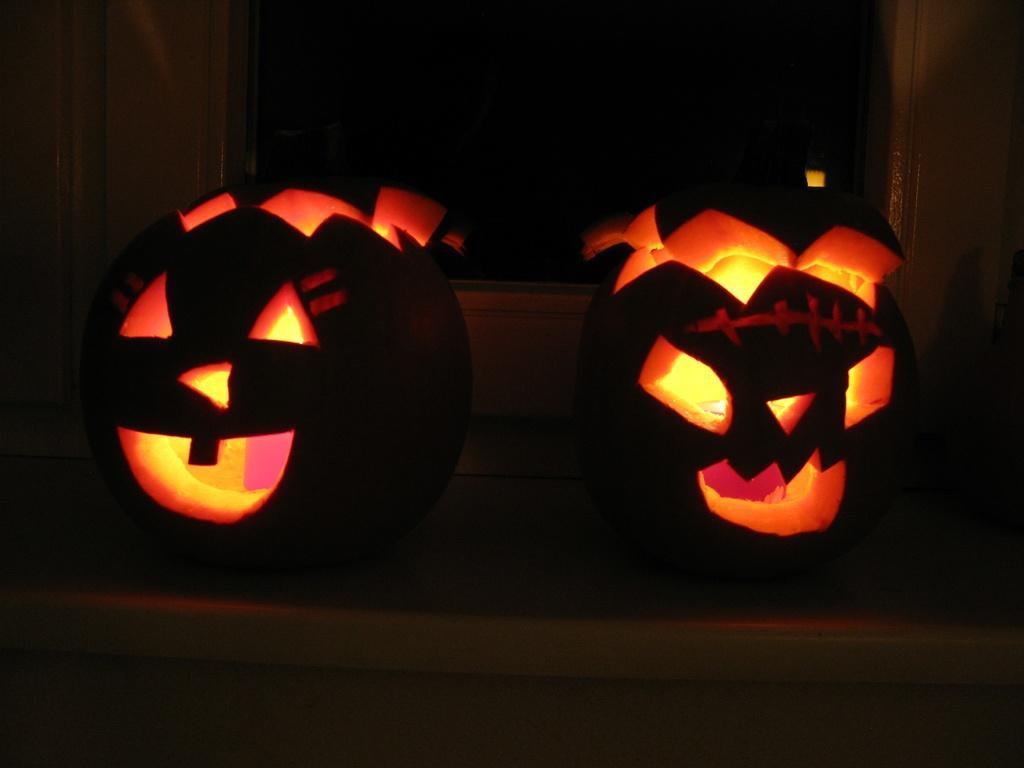Could you give a brief overview of what you see in this image? This picture contains two carved pumpkins. In the background, it is black in color. This picture is clicked in the dark. 